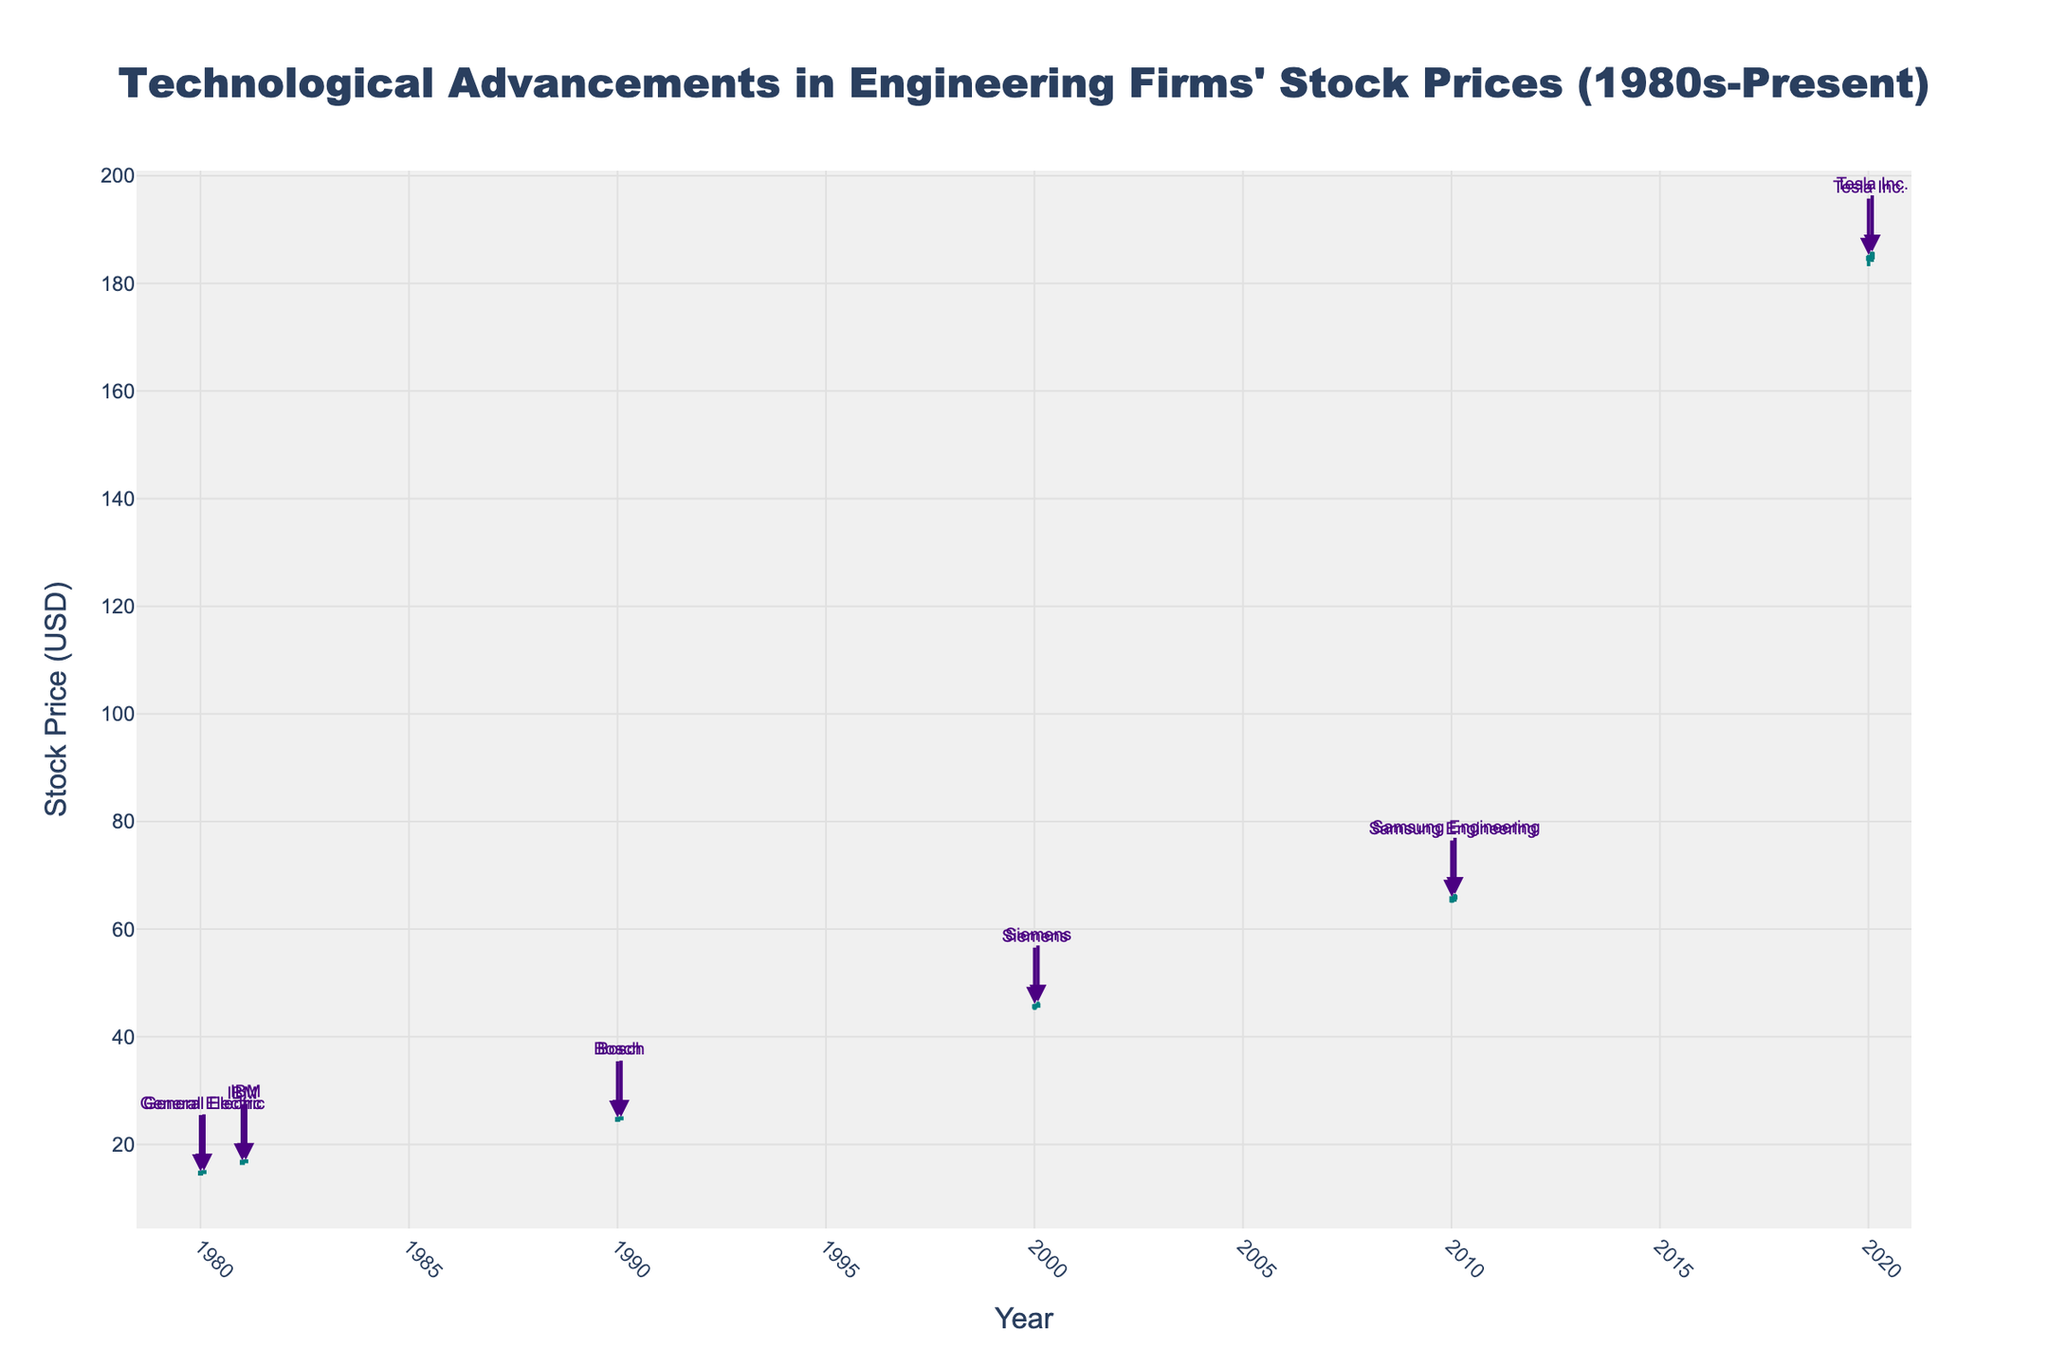What is the title of the chart? The title is located at the top center of the chart and reads: "Technological Advancements in Engineering Firms' Stock Prices (1980s-Present)."
Answer: Technological Advancements in Engineering Firms' Stock Prices (1980s-Present) How does the color of the increasing and decreasing candlesticks differ? The color of the increasing candlesticks is in teal, and the color of the decreasing candlesticks is in dark red. You can see the difference when comparing segments of candlesticks representing price increases and decreases.
Answer: Increasing: teal, Decreasing: dark red Which company has the lowest stock price in the chart, and what is that price? By examining the lowest points of the candlesticks, you can see that General Electric has the lowest stock price at about $14.20 in January 1980. This is marked as the "Low" value on the chart.
Answer: General Electric, $14.20 How many companies’ stock prices are displayed in the chart, and can you name them? Analyzing the annotations connected to each candlestick, there are six companies displayed in the chart: General Electric, IBM, Bosch, Siemens, Samsung Engineering, and Tesla Inc.
Answer: Six; General Electric, IBM, Bosch, Siemens, Samsung Engineering, Tesla Inc Which company had the highest stock price in the year 2020, and what was that price? Observing the candlesticks and the annotations for the year 2020, Tesla Inc. is clearly denoted next to the highest candlestick reaching approximately $185.30, marking the highest price in 2020.
Answer: Tesla Inc., $185.30 What is the difference between the opening price of Samsung Engineering in January 2010 and the closing price of Bosch in February 1990? Samsung Engineering's opening price in January 2010 was approximately $65.30. Bosch's closing price in February 1990 was around $24.90. Subtracting these values results in 65.30 - 24.90 = 40.40.
Answer: $40.40 Comparing the stock prices of IBM in January 1981 and Siemens in January 2000, which had a higher opening price and by how much? IBM had an opening price of $16.50 in January 1981, while Siemens opened at $45.50 in January 2000. The difference is 45.50 - 16.50 = $29.00, indicating Siemens had a higher opening price by $29.00.
Answer: Siemens, $29.00 Did General Electric's stock price increase or decrease between January and February 1980? By how much? General Electric's stock price increased from an opening price of $14.50 in January to a closing price of $14.90 in February. The increase is calculated as 14.90 - 14.50 = $0.40.
Answer: Increased, $0.40 